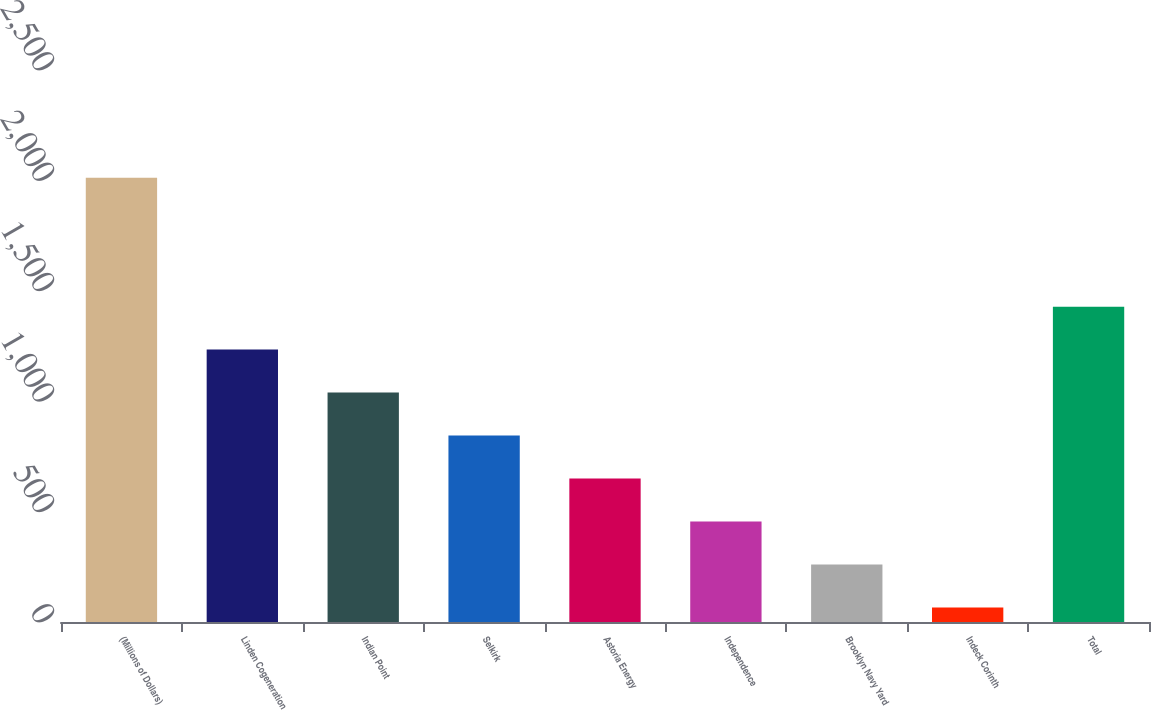<chart> <loc_0><loc_0><loc_500><loc_500><bar_chart><fcel>(Millions of Dollars)<fcel>Linden Cogeneration<fcel>Indian Point<fcel>Selkirk<fcel>Astoria Energy<fcel>Independence<fcel>Brooklyn Navy Yard<fcel>Indeck Corinth<fcel>Total<nl><fcel>2012<fcel>1233.6<fcel>1039<fcel>844.4<fcel>649.8<fcel>455.2<fcel>260.6<fcel>66<fcel>1428.2<nl></chart> 